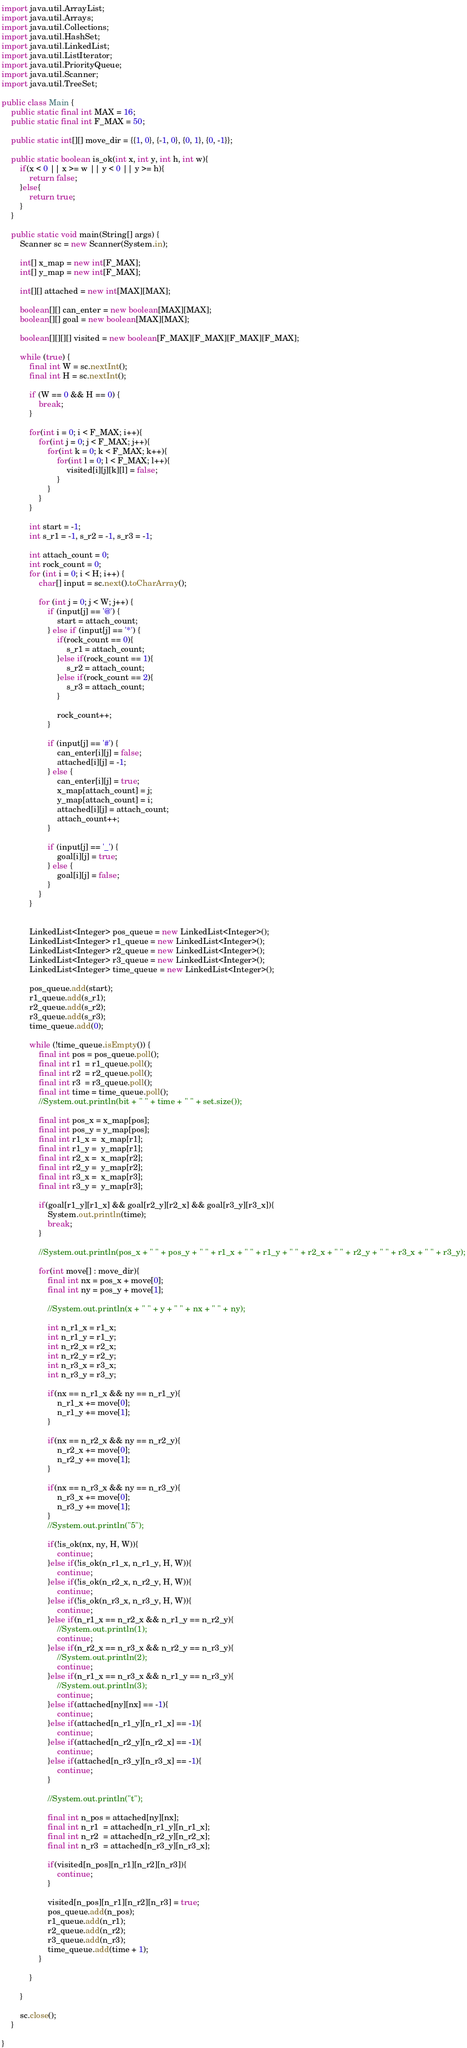Convert code to text. <code><loc_0><loc_0><loc_500><loc_500><_Java_>import java.util.ArrayList;
import java.util.Arrays;
import java.util.Collections;
import java.util.HashSet;
import java.util.LinkedList;
import java.util.ListIterator;
import java.util.PriorityQueue;
import java.util.Scanner;
import java.util.TreeSet;

public class Main {
	public static final int MAX = 16;
	public static final int F_MAX = 50;
	
	public static int[][] move_dir = {{1, 0}, {-1, 0}, {0, 1}, {0, -1}};
	
	public static boolean is_ok(int x, int y, int h, int w){
		if(x < 0 || x >= w || y < 0 || y >= h){
			return false;
		}else{
			return true;
		}
	}

	public static void main(String[] args) {
		Scanner sc = new Scanner(System.in);
		
		int[] x_map = new int[F_MAX];
		int[] y_map = new int[F_MAX];
		
		int[][] attached = new int[MAX][MAX];
		
		boolean[][] can_enter = new boolean[MAX][MAX];
		boolean[][] goal = new boolean[MAX][MAX];
		
		boolean[][][][] visited = new boolean[F_MAX][F_MAX][F_MAX][F_MAX];

		while (true) {
			final int W = sc.nextInt();
			final int H = sc.nextInt();

			if (W == 0 && H == 0) {
				break;
			}
			
			for(int i = 0; i < F_MAX; i++){
				for(int j = 0; j < F_MAX; j++){
					for(int k = 0; k < F_MAX; k++){
						for(int l = 0; l < F_MAX; l++){
							visited[i][j][k][l] = false;
						}
					}
				}
			}

			int start = -1;
			int s_r1 = -1, s_r2 = -1, s_r3 = -1;
			
			int attach_count = 0;
			int rock_count = 0;
			for (int i = 0; i < H; i++) {
				char[] input = sc.next().toCharArray();

				for (int j = 0; j < W; j++) {
					if (input[j] == '@') {
						start = attach_count;
					} else if (input[j] == '*') {
						if(rock_count == 0){
							s_r1 = attach_count;
						}else if(rock_count == 1){
							s_r2 = attach_count;
						}else if(rock_count == 2){
							s_r3 = attach_count;
						}
						
						rock_count++;
					}
					
					if (input[j] == '#') {
						can_enter[i][j] = false;
						attached[i][j] = -1;
					} else {
						can_enter[i][j] = true;
						x_map[attach_count] = j;
						y_map[attach_count] = i;
						attached[i][j] = attach_count;
						attach_count++;
					}

					if (input[j] == '_') {
						goal[i][j] = true;
					} else {
						goal[i][j] = false;
					}
				}
			}

		
			LinkedList<Integer> pos_queue = new LinkedList<Integer>();
			LinkedList<Integer> r1_queue = new LinkedList<Integer>();
			LinkedList<Integer> r2_queue = new LinkedList<Integer>();
			LinkedList<Integer> r3_queue = new LinkedList<Integer>();
			LinkedList<Integer> time_queue = new LinkedList<Integer>();
			
			pos_queue.add(start);
			r1_queue.add(s_r1);
			r2_queue.add(s_r2);
			r3_queue.add(s_r3);
			time_queue.add(0);

			while (!time_queue.isEmpty()) {
				final int pos = pos_queue.poll();
				final int r1  = r1_queue.poll();
				final int r2  = r2_queue.poll();
				final int r3  = r3_queue.poll();
				final int time = time_queue.poll();
				//System.out.println(bit + " " + time + " " + set.size());
				
				final int pos_x = x_map[pos];
				final int pos_y = y_map[pos];
				final int r1_x =  x_map[r1];
				final int r1_y =  y_map[r1];
				final int r2_x =  x_map[r2];
				final int r2_y =  y_map[r2];
				final int r3_x =  x_map[r3];
				final int r3_y =  y_map[r3];
				
				if(goal[r1_y][r1_x] && goal[r2_y][r2_x] && goal[r3_y][r3_x]){
					System.out.println(time);
					break;
				}
				
				//System.out.println(pos_x + " " + pos_y + " " + r1_x + " " + r1_y + " " + r2_x + " " + r2_y + " " + r3_x + " " + r3_y);
				
				for(int move[] : move_dir){
					final int nx = pos_x + move[0];
					final int ny = pos_y + move[1];
					
					//System.out.println(x + " " + y + " " + nx + " " + ny);
					
					int n_r1_x = r1_x;
					int n_r1_y = r1_y;
					int n_r2_x = r2_x;
					int n_r2_y = r2_y;
					int n_r3_x = r3_x;
					int n_r3_y = r3_y;
					
					if(nx == n_r1_x && ny == n_r1_y){
						n_r1_x += move[0];
						n_r1_y += move[1];
					}
					
					if(nx == n_r2_x && ny == n_r2_y){
						n_r2_x += move[0];
						n_r2_y += move[1];
					}
					
					if(nx == n_r3_x && ny == n_r3_y){
						n_r3_x += move[0];
						n_r3_y += move[1];
					}
					//System.out.println("5");
					
					if(!is_ok(nx, ny, H, W)){
						continue;
					}else if(!is_ok(n_r1_x, n_r1_y, H, W)){
						continue;
					}else if(!is_ok(n_r2_x, n_r2_y, H, W)){
						continue;
					}else if(!is_ok(n_r3_x, n_r3_y, H, W)){
						continue;
					}else if(n_r1_x == n_r2_x && n_r1_y == n_r2_y){
						//System.out.println(1);
						continue;
					}else if(n_r2_x == n_r3_x && n_r2_y == n_r3_y){
						//System.out.println(2);
						continue;
					}else if(n_r1_x == n_r3_x && n_r1_y == n_r3_y){
						//System.out.println(3);
						continue;
					}else if(attached[ny][nx] == -1){
						continue;
					}else if(attached[n_r1_y][n_r1_x] == -1){
						continue;
					}else if(attached[n_r2_y][n_r2_x] == -1){
						continue;
					}else if(attached[n_r3_y][n_r3_x] == -1){
						continue;
					}
					
					//System.out.println("t");
					
					final int n_pos = attached[ny][nx];
					final int n_r1  = attached[n_r1_y][n_r1_x];
					final int n_r2  = attached[n_r2_y][n_r2_x];
					final int n_r3  = attached[n_r3_y][n_r3_x];
					
					if(visited[n_pos][n_r1][n_r2][n_r3]){
						continue;
					}
					
					visited[n_pos][n_r1][n_r2][n_r3] = true;
					pos_queue.add(n_pos);
					r1_queue.add(n_r1);
					r2_queue.add(n_r2);
					r3_queue.add(n_r3);
					time_queue.add(time + 1);
				}
				
			}

		}

		sc.close();
	}

}</code> 